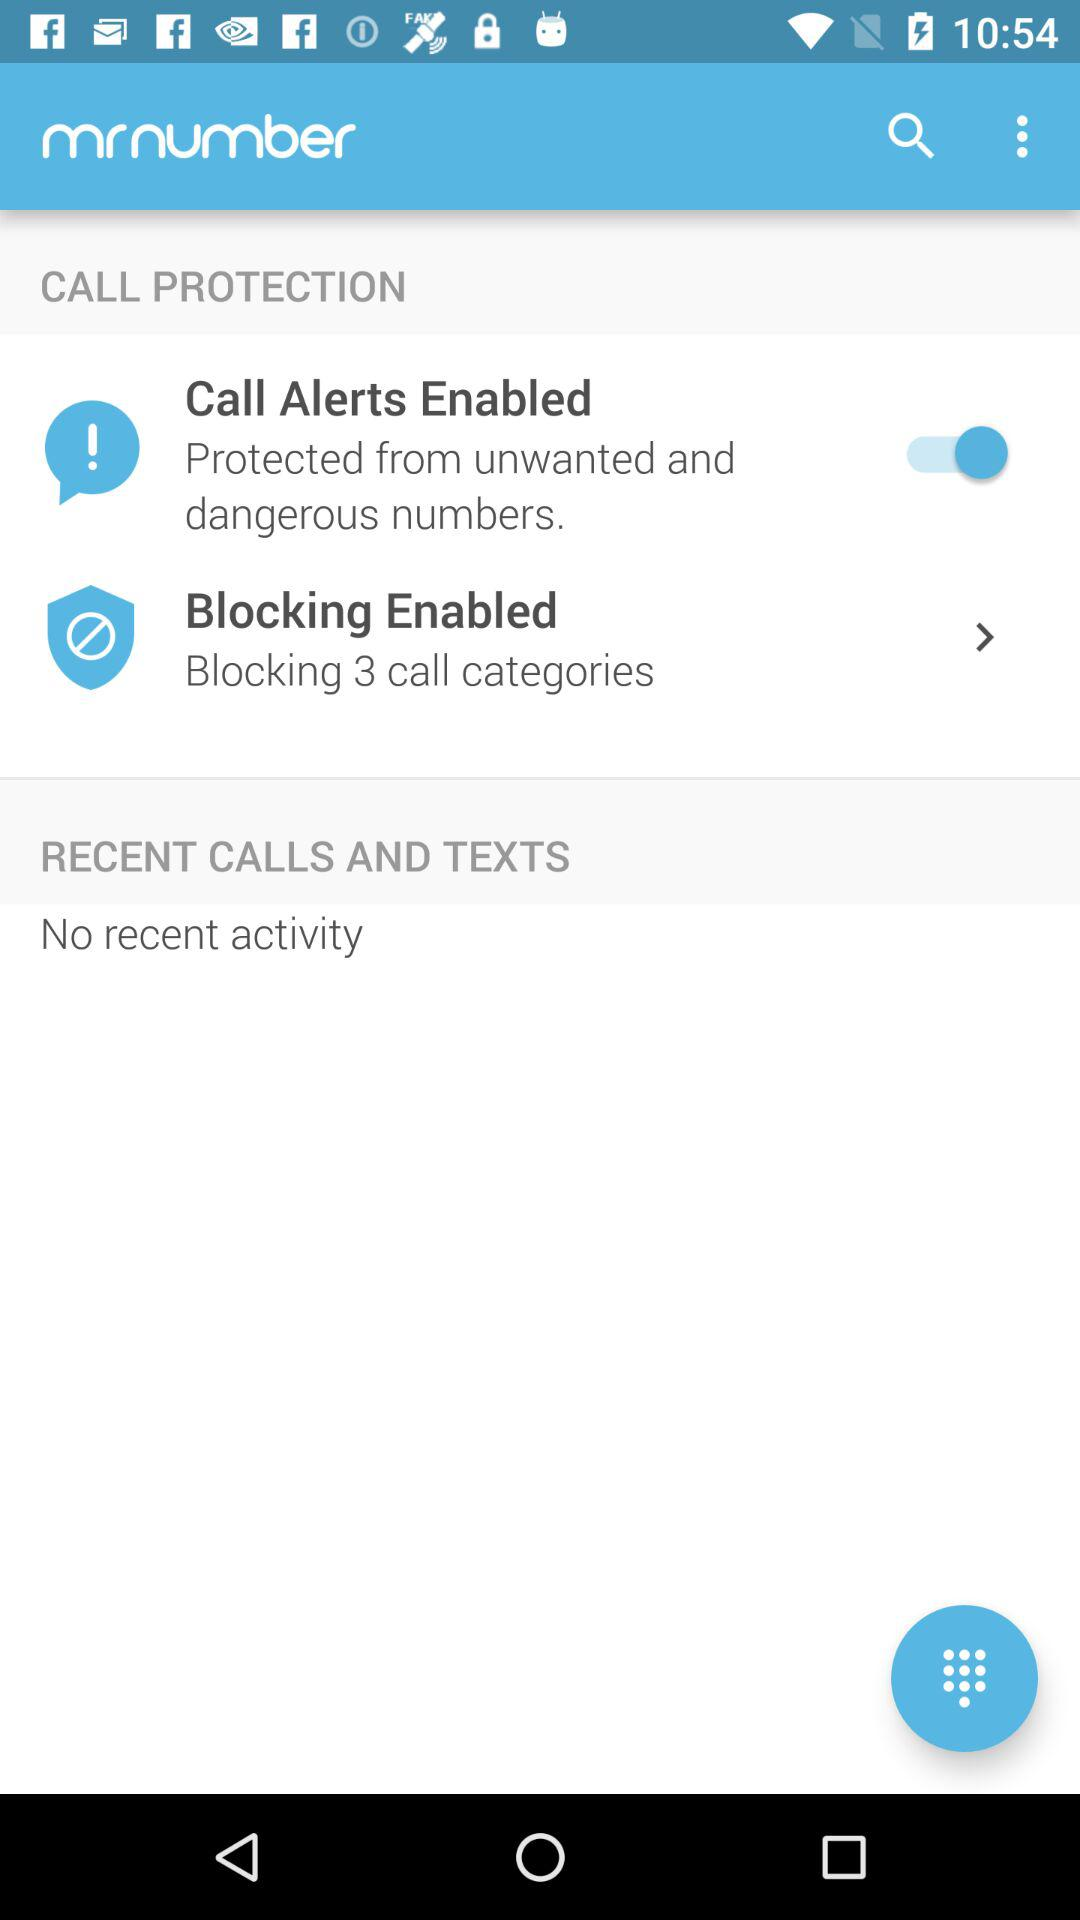How many call categories are blocked? There are 3 blocked call categories. 